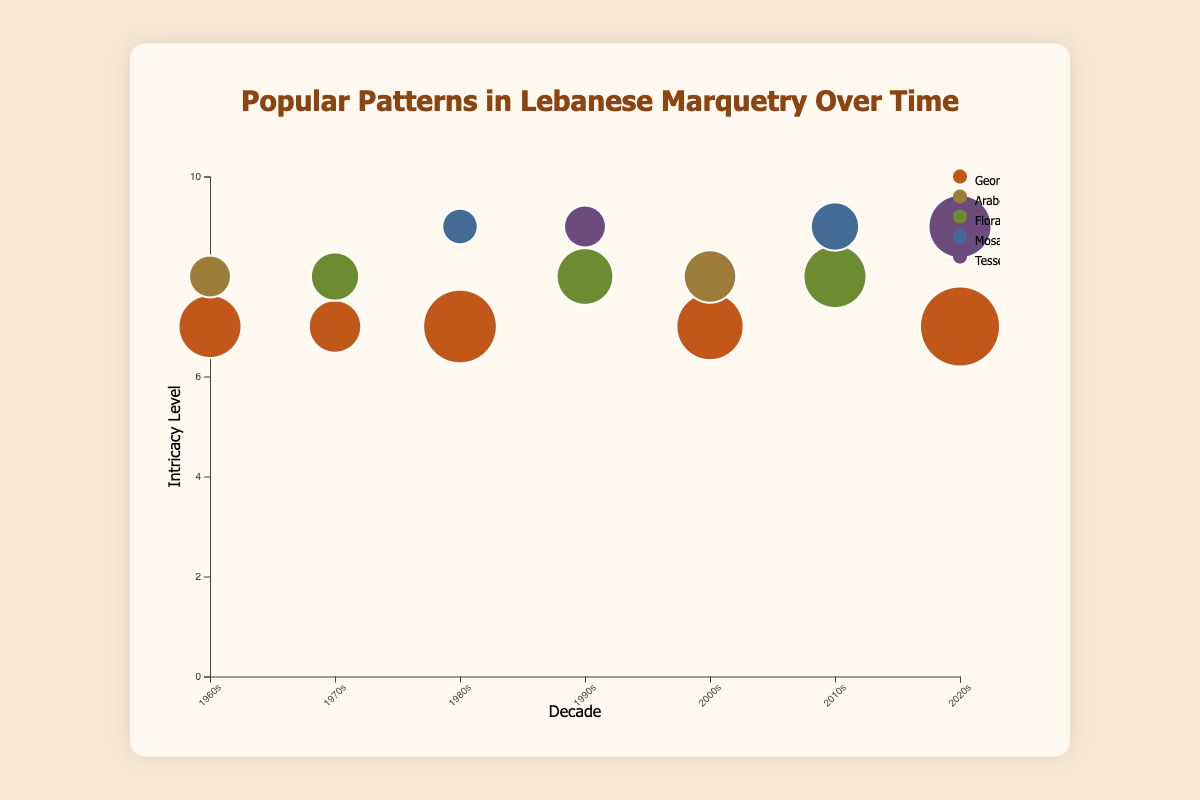What is the title of the chart? The title can be found at the top of the chart and it summarizes what the chart is showing.
Answer: "Popular Patterns in Lebanese Marquetry Over Time" Which pattern was most frequently used in the 2020s? Find the bubbles in the 2020s column and compare their sizes to determine which is the largest.
Answer: "Geometric Stars" What is the range of intricacy levels shown on the y-axis? Look at the values on the y-axis to determine the minimum and maximum levels of intricacy displayed.
Answer: 0 to 10 How many different patterns have been used from the 1960s to the 2020s? Identify and count the distinct patterns listed in the legend.
Answer: 5 Which decade had the highest overall frequency of patterns? Sum the frequencies of all patterns in each decade and compare to find the highest total.
Answer: 2020s What is the color used for "Floral Rosettes"? Look at the legend and identify the color next to the text "Floral Rosettes."
Answer: Green Between "Mosaic Patterns" and "Tessellations," which has a higher average intricacy level over the decades? Calculate the average intricacy level for each pattern by summing their intricacy levels and dividing by the number of decades they appear in.
Answer: Tessellations Compare the frequency of "Arabesque" patterns in the 1960s and 2000s. Which decade had a higher frequency? Locate the bubbles for "Arabesque" in the 1960s and 2000s columns and compare their sizes.
Answer: 2000s What pattern appears most frequently in multiple decades? Identify the pattern with the highest frequency in the majority of the decade columns.
Answer: "Geometric Stars" Which patterns have an intricacy level of 9 in any decade? Look at the y-axis and identify bubbles at the 9 mark, then check the patterns for these bubbles.
Answer: "Mosaic Patterns" and "Tessellations" 